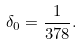<formula> <loc_0><loc_0><loc_500><loc_500>\delta _ { 0 } = \frac { 1 } { 3 7 8 } .</formula> 